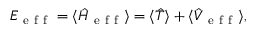Convert formula to latex. <formula><loc_0><loc_0><loc_500><loc_500>E _ { e f f } = \langle \hat { H } _ { e f f } \rangle = \langle \hat { T } \rangle + \langle \hat { V } _ { e f f } \rangle ,</formula> 